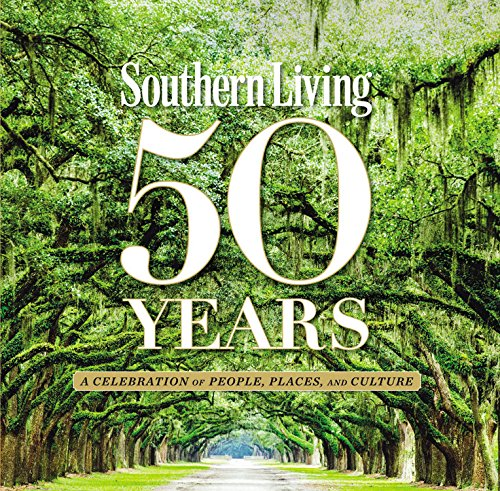How does this book contribute to the preservation of Southern culture? The book serves as a cultural time capsule, preserving stories, traditions, and recipes that define Southern living. By documenting these aspects, it helps keep the unique Southern heritage alive for future generations, offering an educational resource that celebrates and perpetuates the distinct ways of life in the Southern states. 